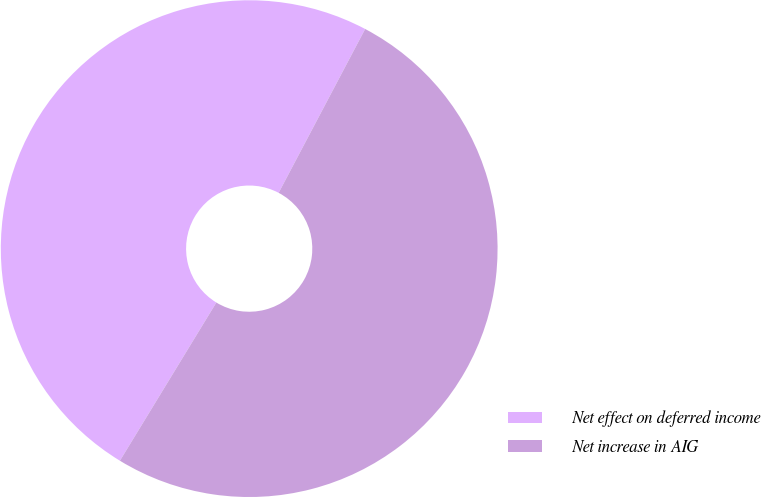Convert chart. <chart><loc_0><loc_0><loc_500><loc_500><pie_chart><fcel>Net effect on deferred income<fcel>Net increase in AIG<nl><fcel>49.02%<fcel>50.98%<nl></chart> 